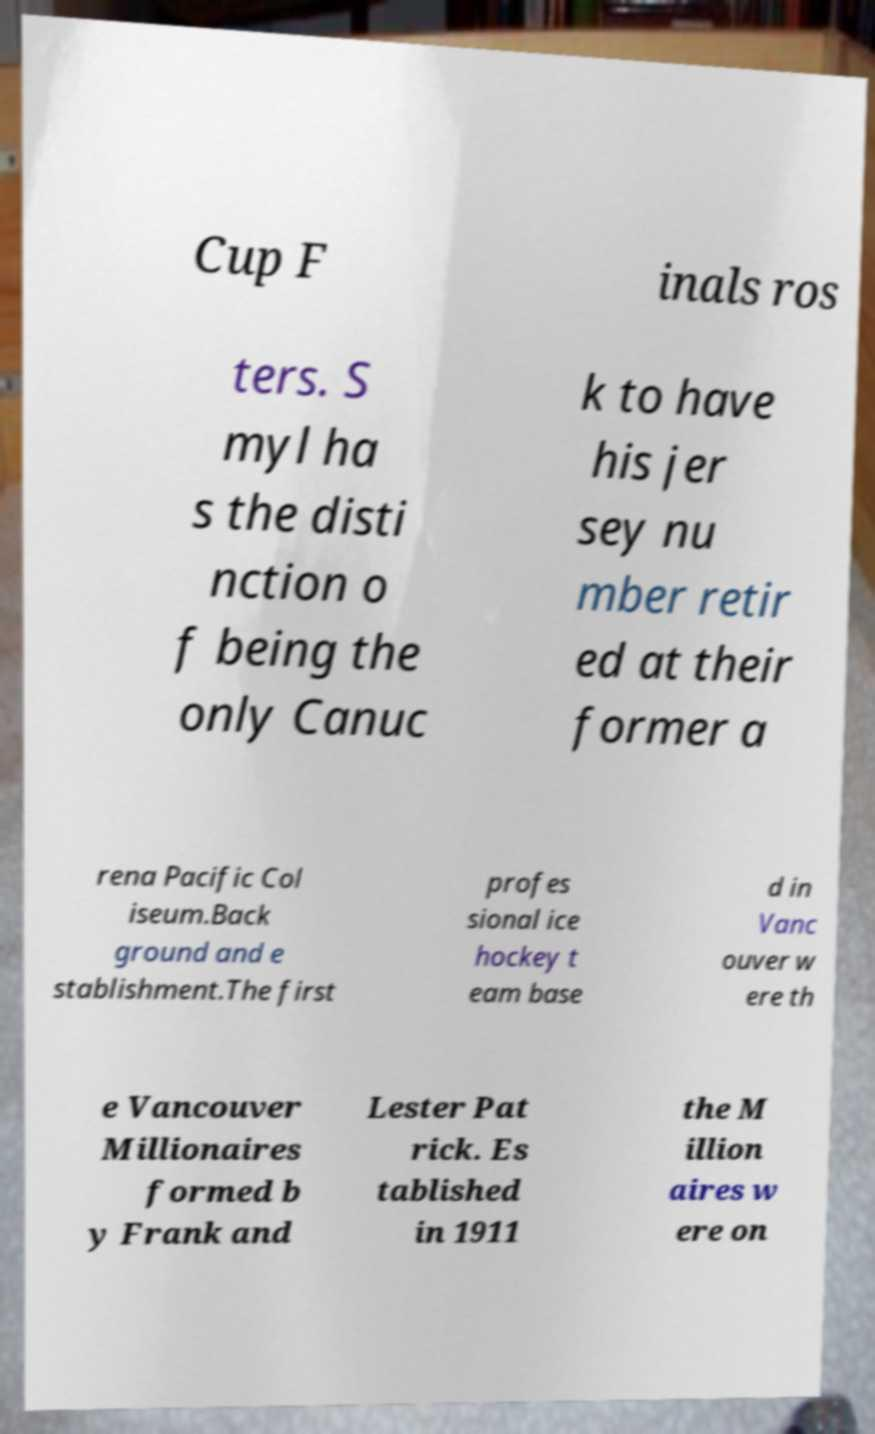I need the written content from this picture converted into text. Can you do that? Cup F inals ros ters. S myl ha s the disti nction o f being the only Canuc k to have his jer sey nu mber retir ed at their former a rena Pacific Col iseum.Back ground and e stablishment.The first profes sional ice hockey t eam base d in Vanc ouver w ere th e Vancouver Millionaires formed b y Frank and Lester Pat rick. Es tablished in 1911 the M illion aires w ere on 